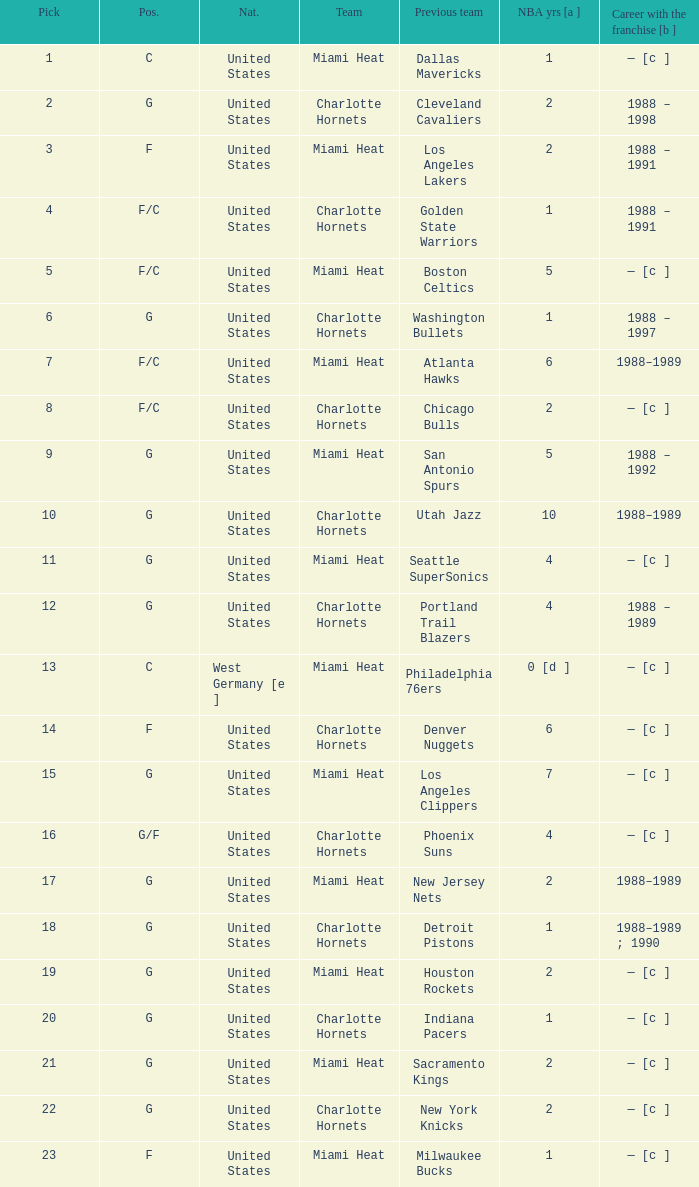How many NBA years did the player from the United States who was previously on the los angeles lakers have? 2.0. 